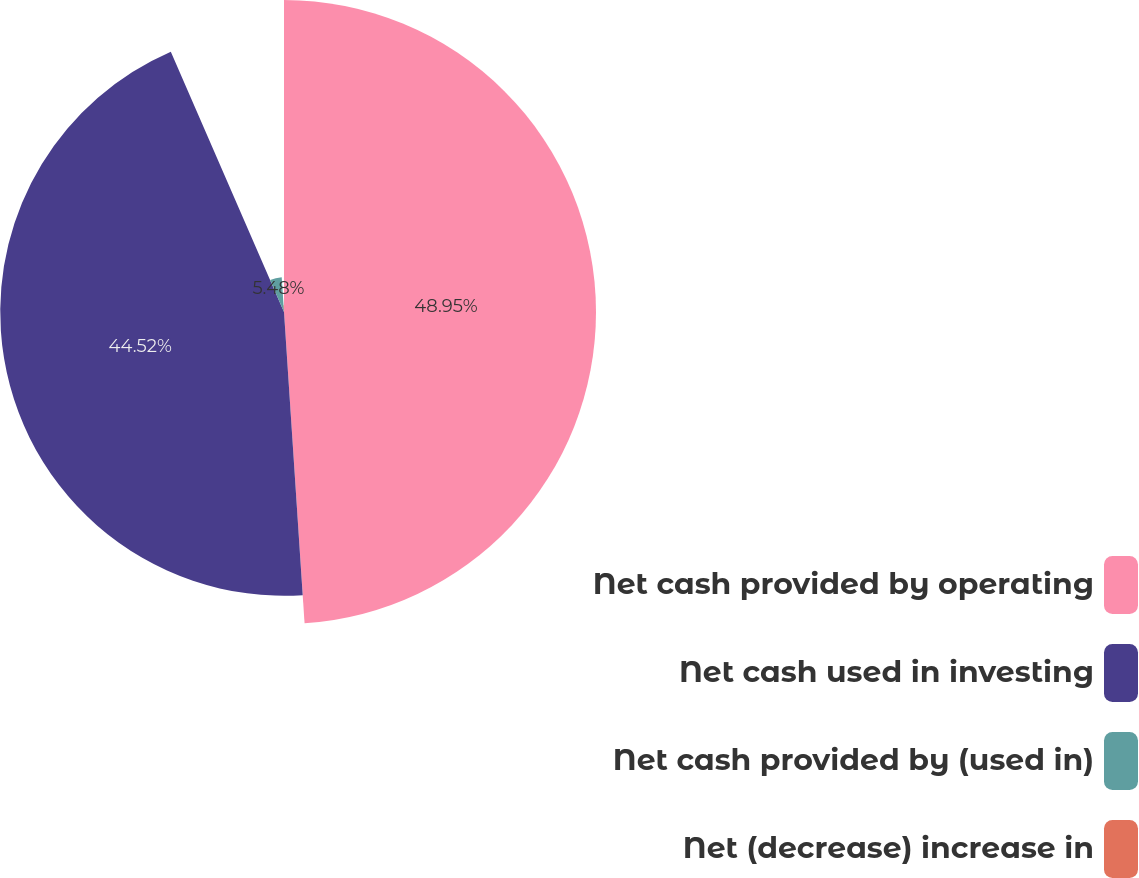Convert chart. <chart><loc_0><loc_0><loc_500><loc_500><pie_chart><fcel>Net cash provided by operating<fcel>Net cash used in investing<fcel>Net cash provided by (used in)<fcel>Net (decrease) increase in<nl><fcel>48.95%<fcel>44.52%<fcel>5.48%<fcel>1.05%<nl></chart> 